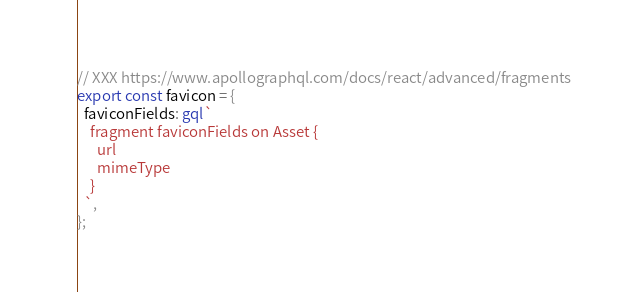Convert code to text. <code><loc_0><loc_0><loc_500><loc_500><_TypeScript_>
// XXX https://www.apollographql.com/docs/react/advanced/fragments
export const favicon = {
  faviconFields: gql`
    fragment faviconFields on Asset {
      url
      mimeType
    }
  `,
};
</code> 